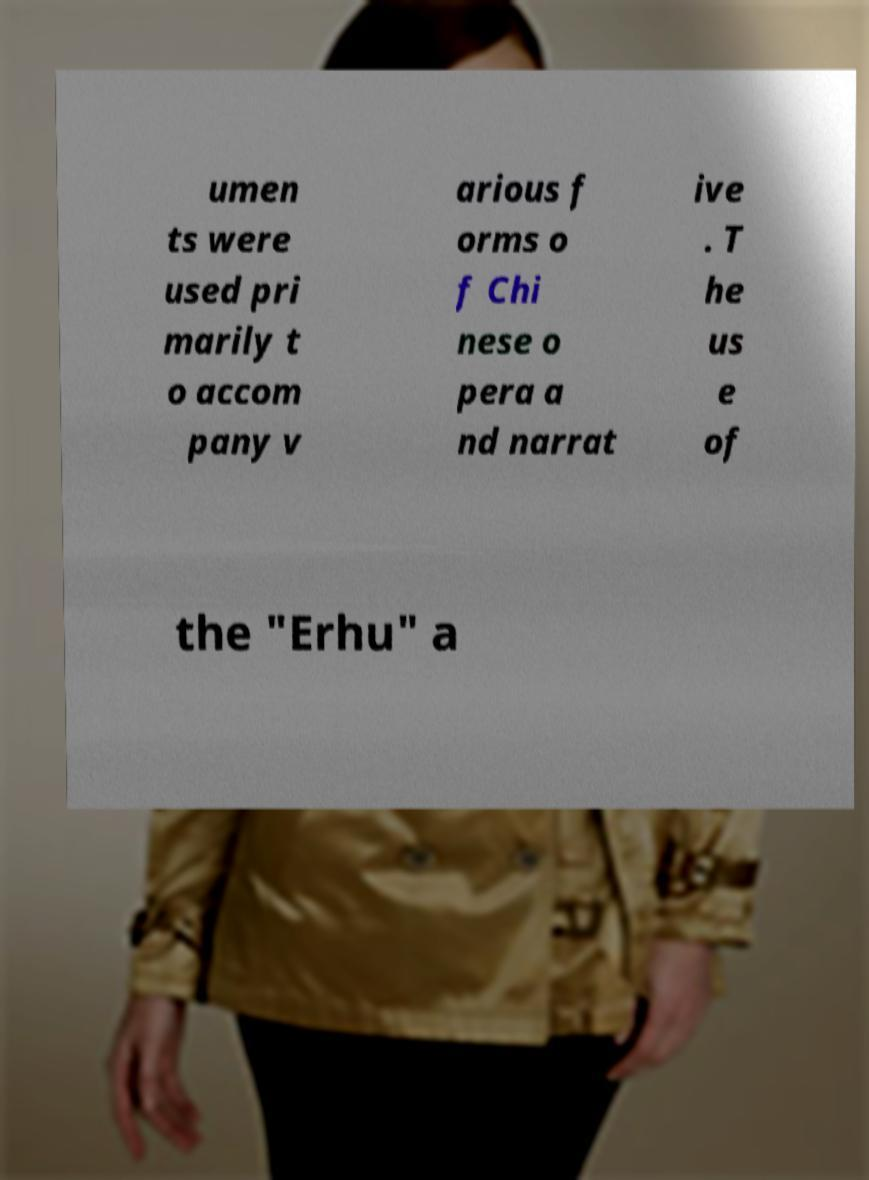Please read and relay the text visible in this image. What does it say? umen ts were used pri marily t o accom pany v arious f orms o f Chi nese o pera a nd narrat ive . T he us e of the "Erhu" a 